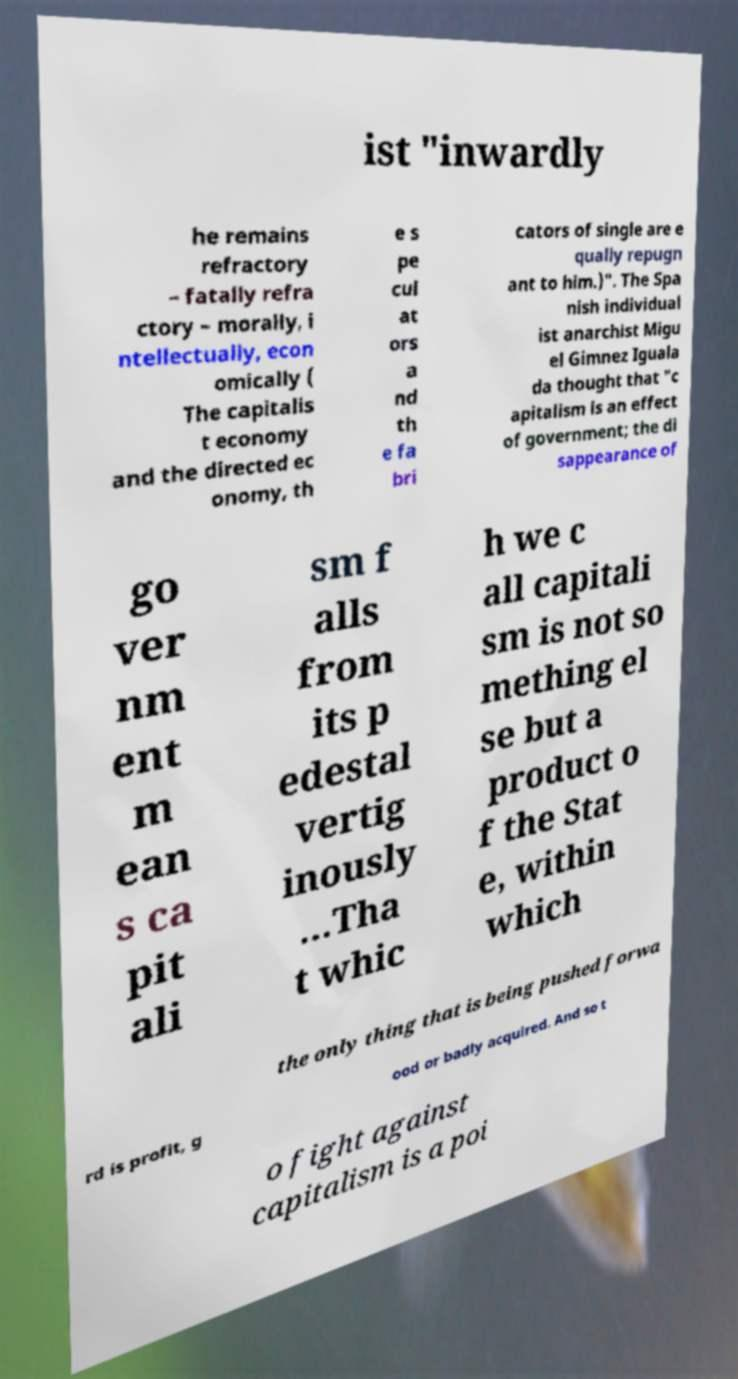Can you accurately transcribe the text from the provided image for me? ist "inwardly he remains refractory – fatally refra ctory – morally, i ntellectually, econ omically ( The capitalis t economy and the directed ec onomy, th e s pe cul at ors a nd th e fa bri cators of single are e qually repugn ant to him.)". The Spa nish individual ist anarchist Migu el Gimnez Iguala da thought that "c apitalism is an effect of government; the di sappearance of go ver nm ent m ean s ca pit ali sm f alls from its p edestal vertig inously ...Tha t whic h we c all capitali sm is not so mething el se but a product o f the Stat e, within which the only thing that is being pushed forwa rd is profit, g ood or badly acquired. And so t o fight against capitalism is a poi 